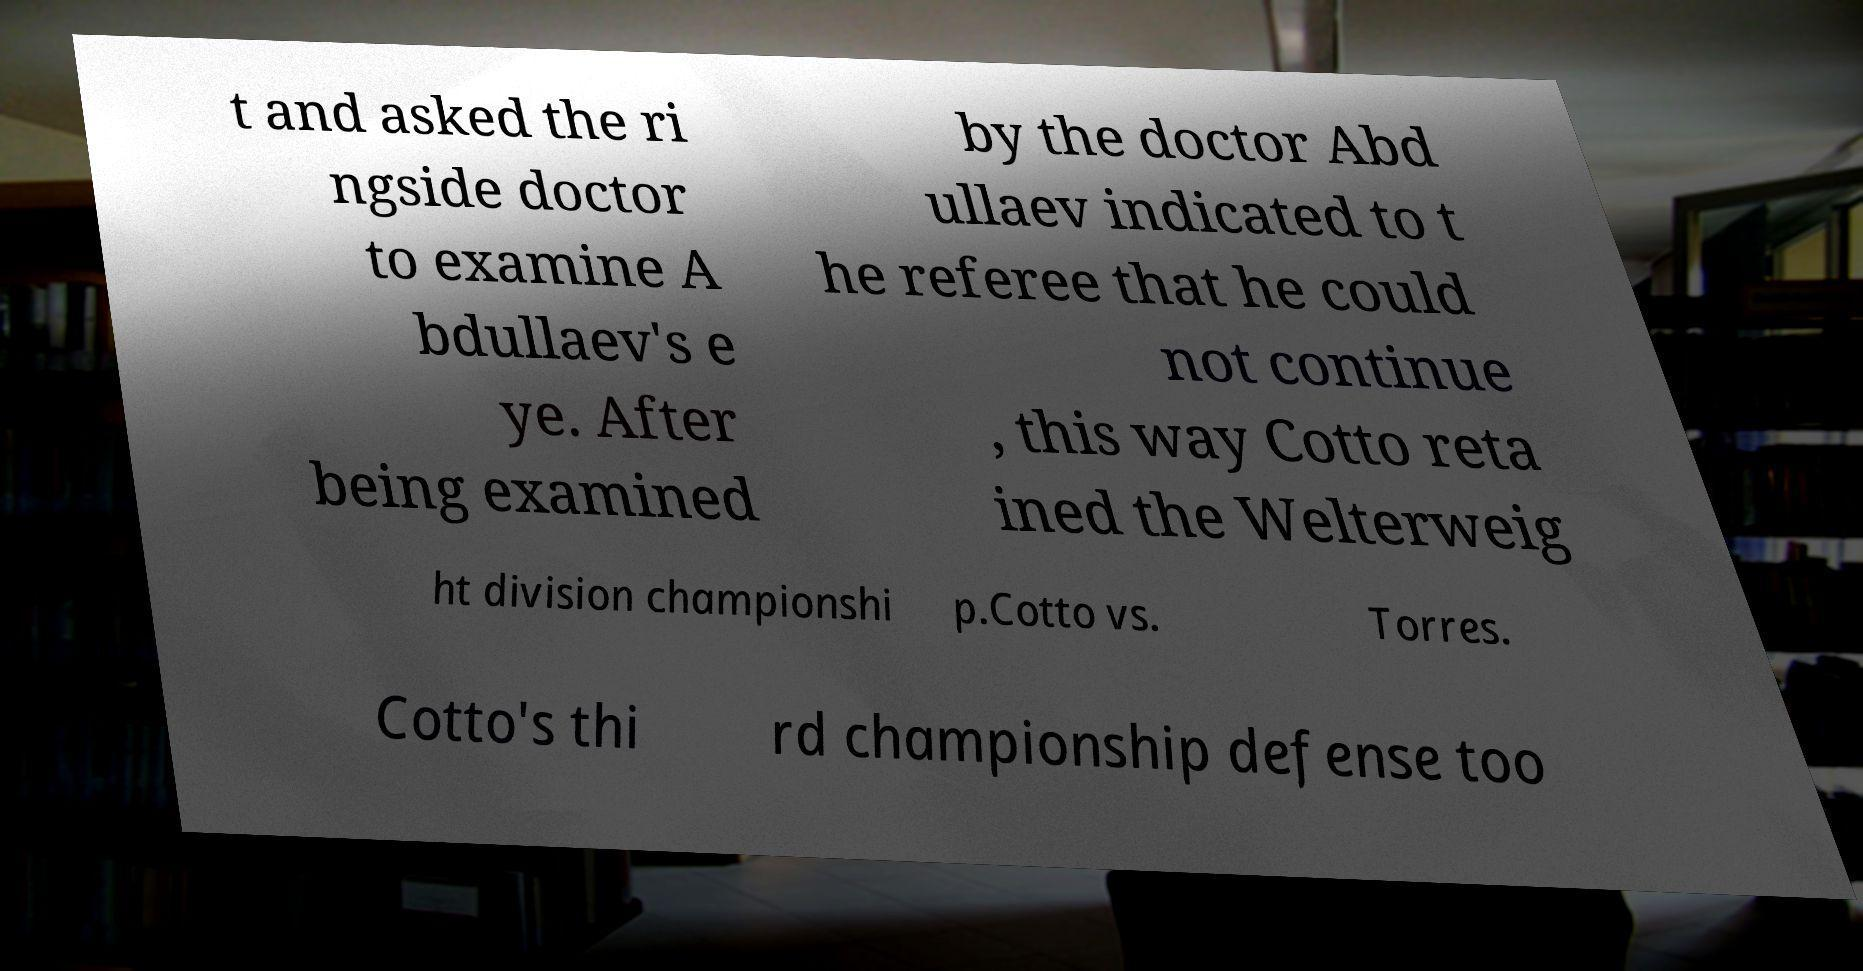What messages or text are displayed in this image? I need them in a readable, typed format. t and asked the ri ngside doctor to examine A bdullaev's e ye. After being examined by the doctor Abd ullaev indicated to t he referee that he could not continue , this way Cotto reta ined the Welterweig ht division championshi p.Cotto vs. Torres. Cotto's thi rd championship defense too 